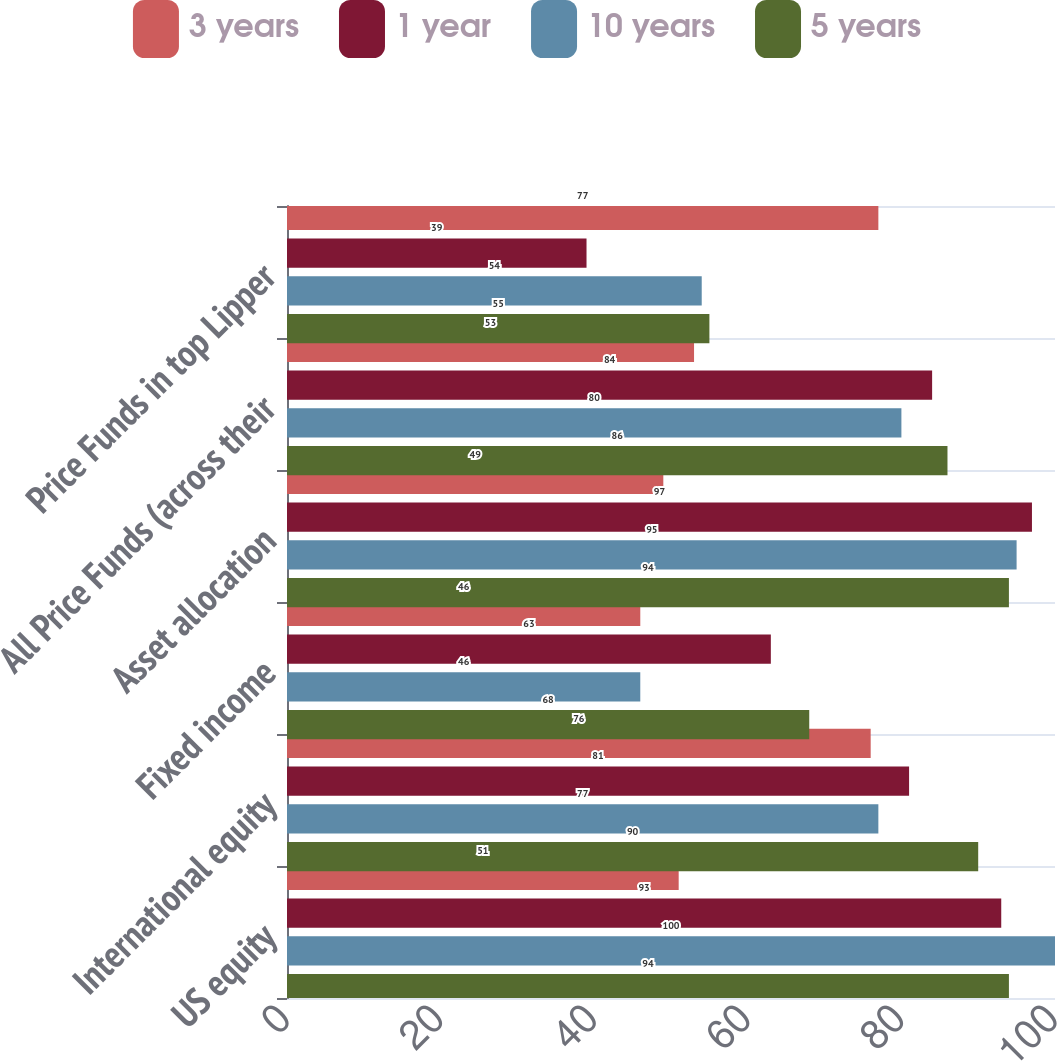Convert chart to OTSL. <chart><loc_0><loc_0><loc_500><loc_500><stacked_bar_chart><ecel><fcel>US equity<fcel>International equity<fcel>Fixed income<fcel>Asset allocation<fcel>All Price Funds (across their<fcel>Price Funds in top Lipper<nl><fcel>3 years<fcel>51<fcel>76<fcel>46<fcel>49<fcel>53<fcel>77<nl><fcel>1 year<fcel>93<fcel>81<fcel>63<fcel>97<fcel>84<fcel>39<nl><fcel>10 years<fcel>100<fcel>77<fcel>46<fcel>95<fcel>80<fcel>54<nl><fcel>5 years<fcel>94<fcel>90<fcel>68<fcel>94<fcel>86<fcel>55<nl></chart> 